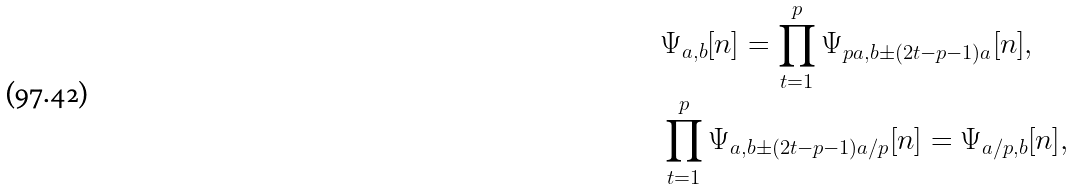<formula> <loc_0><loc_0><loc_500><loc_500>& \Psi _ { a , b } [ n ] = \prod _ { t = 1 } ^ { p } \Psi _ { p a , b \pm ( 2 t - p - 1 ) a } [ n ] , \\ & \prod _ { t = 1 } ^ { p } \Psi _ { a , b \pm ( 2 t - p - 1 ) a / p } [ n ] = \Psi _ { a / p , b } [ n ] ,</formula> 